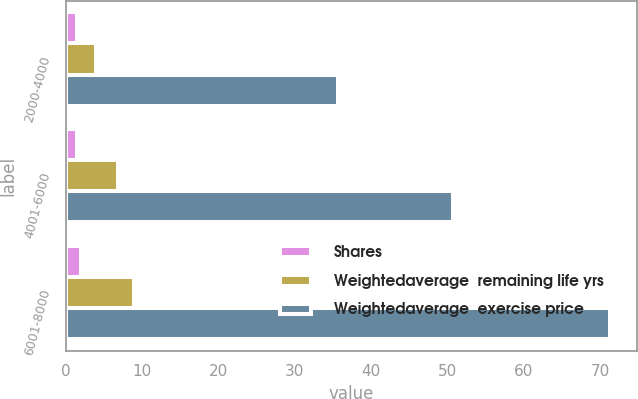Convert chart to OTSL. <chart><loc_0><loc_0><loc_500><loc_500><stacked_bar_chart><ecel><fcel>2000-4000<fcel>4001-6000<fcel>6001-8000<nl><fcel>Shares<fcel>1.4<fcel>1.5<fcel>1.9<nl><fcel>Weightedaverage  remaining life yrs<fcel>3.9<fcel>6.8<fcel>8.9<nl><fcel>Weightedaverage  exercise price<fcel>35.71<fcel>50.77<fcel>71.33<nl></chart> 